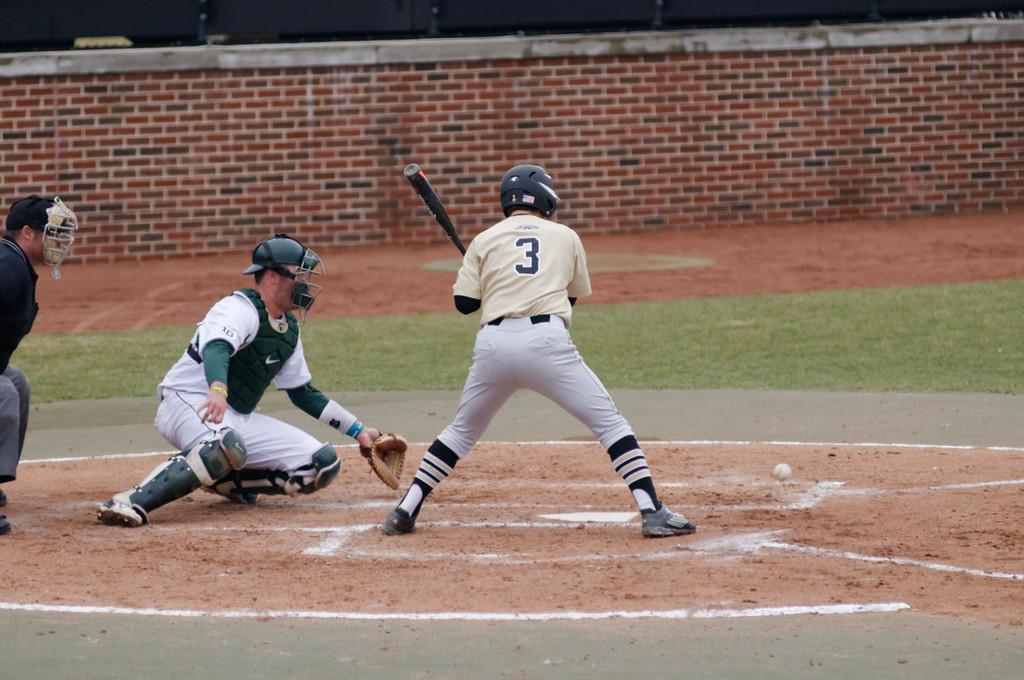<image>
Provide a brief description of the given image. A baseball player with 3 on his uniform at bat. 